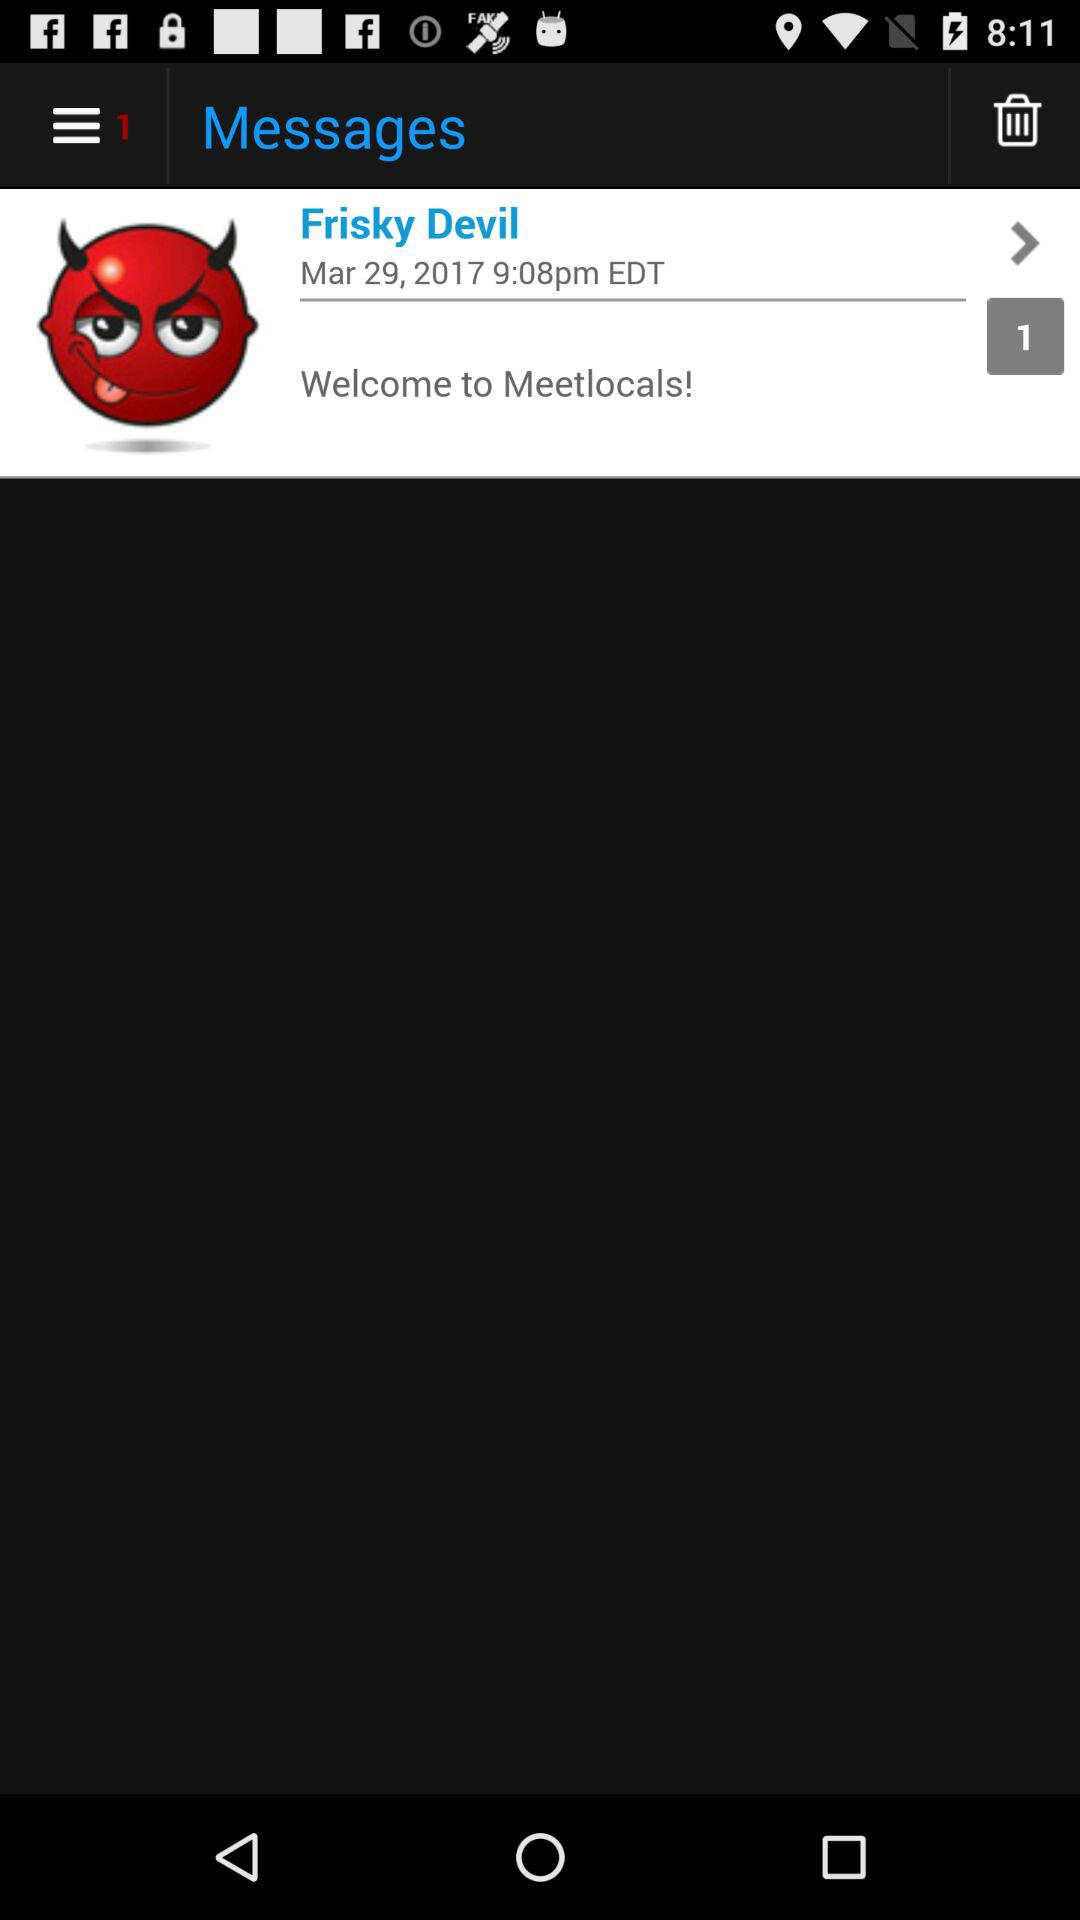What is the date of the message? The date is March 29, 2017. 